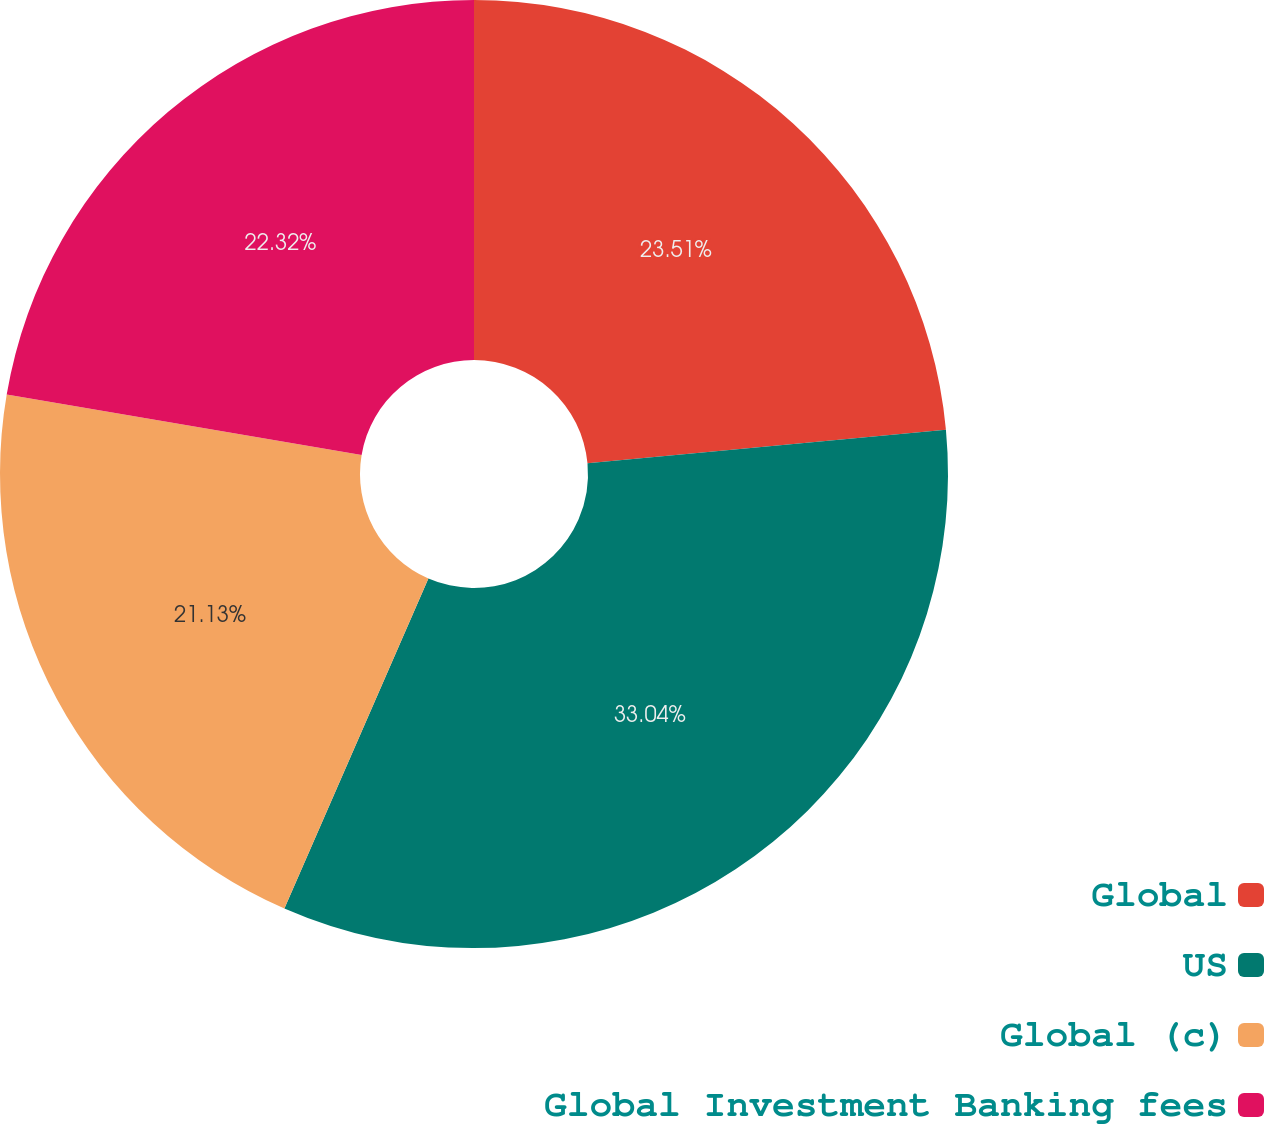<chart> <loc_0><loc_0><loc_500><loc_500><pie_chart><fcel>Global<fcel>US<fcel>Global (c)<fcel>Global Investment Banking fees<nl><fcel>23.51%<fcel>33.04%<fcel>21.13%<fcel>22.32%<nl></chart> 